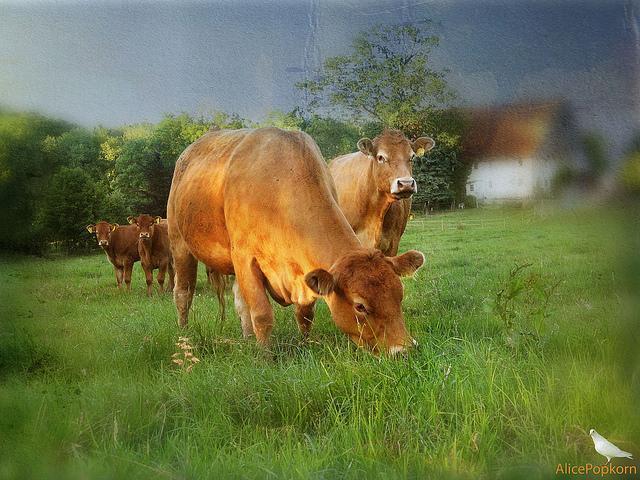How many cows are there?
Give a very brief answer. 4. 